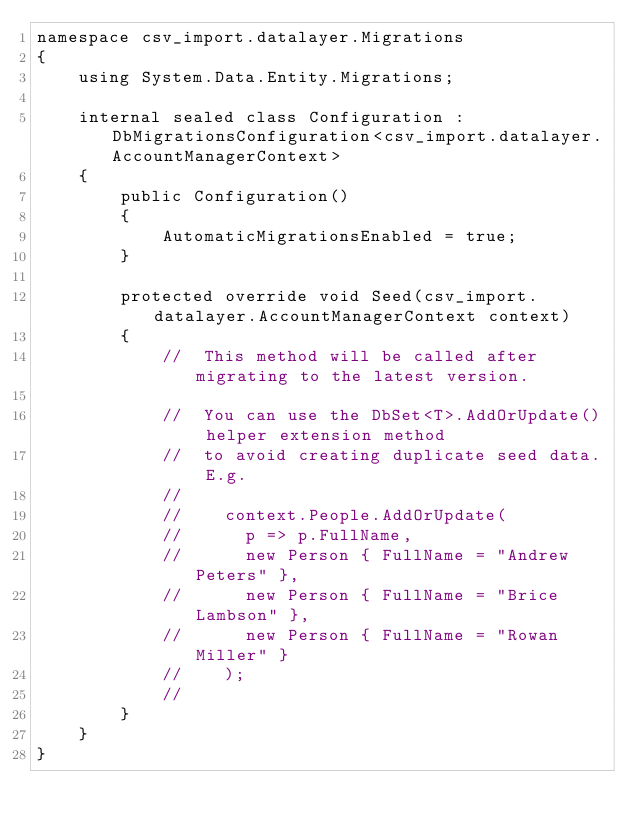Convert code to text. <code><loc_0><loc_0><loc_500><loc_500><_C#_>namespace csv_import.datalayer.Migrations
{
    using System.Data.Entity.Migrations;

    internal sealed class Configuration : DbMigrationsConfiguration<csv_import.datalayer.AccountManagerContext>
    {
        public Configuration()
        {
            AutomaticMigrationsEnabled = true;
        }

        protected override void Seed(csv_import.datalayer.AccountManagerContext context)
        {
            //  This method will be called after migrating to the latest version.

            //  You can use the DbSet<T>.AddOrUpdate() helper extension method 
            //  to avoid creating duplicate seed data. E.g.
            //
            //    context.People.AddOrUpdate(
            //      p => p.FullName,
            //      new Person { FullName = "Andrew Peters" },
            //      new Person { FullName = "Brice Lambson" },
            //      new Person { FullName = "Rowan Miller" }
            //    );
            //
        }
    }
}
</code> 